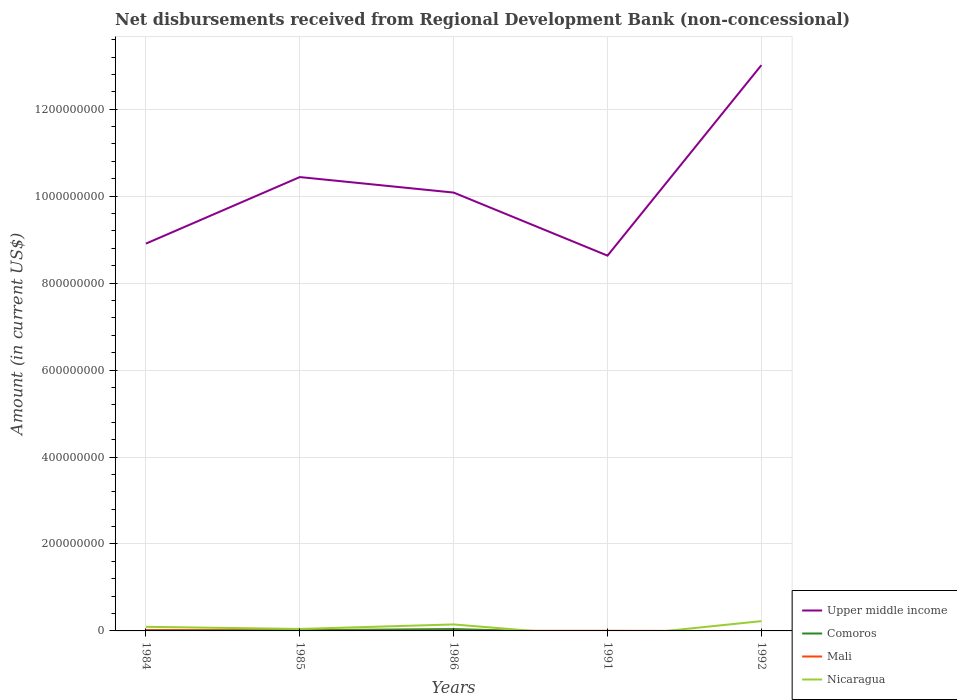How many different coloured lines are there?
Provide a short and direct response. 4. Does the line corresponding to Mali intersect with the line corresponding to Upper middle income?
Keep it short and to the point. No. Across all years, what is the maximum amount of disbursements received from Regional Development Bank in Comoros?
Your answer should be very brief. 0. What is the total amount of disbursements received from Regional Development Bank in Upper middle income in the graph?
Keep it short and to the point. -1.17e+08. What is the difference between the highest and the second highest amount of disbursements received from Regional Development Bank in Mali?
Keep it short and to the point. 1.83e+06. What is the difference between the highest and the lowest amount of disbursements received from Regional Development Bank in Mali?
Provide a short and direct response. 1. How many lines are there?
Provide a short and direct response. 4. What is the difference between two consecutive major ticks on the Y-axis?
Your answer should be compact. 2.00e+08. Does the graph contain any zero values?
Provide a succinct answer. Yes. Does the graph contain grids?
Offer a very short reply. Yes. How are the legend labels stacked?
Provide a succinct answer. Vertical. What is the title of the graph?
Offer a very short reply. Net disbursements received from Regional Development Bank (non-concessional). What is the label or title of the X-axis?
Your response must be concise. Years. What is the label or title of the Y-axis?
Keep it short and to the point. Amount (in current US$). What is the Amount (in current US$) in Upper middle income in 1984?
Offer a terse response. 8.91e+08. What is the Amount (in current US$) in Comoros in 1984?
Your answer should be very brief. 1.78e+06. What is the Amount (in current US$) of Mali in 1984?
Your response must be concise. 1.83e+06. What is the Amount (in current US$) of Nicaragua in 1984?
Make the answer very short. 9.44e+06. What is the Amount (in current US$) in Upper middle income in 1985?
Provide a succinct answer. 1.04e+09. What is the Amount (in current US$) of Comoros in 1985?
Ensure brevity in your answer.  1.66e+06. What is the Amount (in current US$) in Nicaragua in 1985?
Provide a short and direct response. 4.54e+06. What is the Amount (in current US$) of Upper middle income in 1986?
Provide a succinct answer. 1.01e+09. What is the Amount (in current US$) of Comoros in 1986?
Offer a very short reply. 4.27e+06. What is the Amount (in current US$) of Mali in 1986?
Offer a terse response. 3.03e+05. What is the Amount (in current US$) in Nicaragua in 1986?
Offer a terse response. 1.49e+07. What is the Amount (in current US$) of Upper middle income in 1991?
Your answer should be very brief. 8.63e+08. What is the Amount (in current US$) in Comoros in 1991?
Your answer should be very brief. 0. What is the Amount (in current US$) in Mali in 1991?
Your answer should be very brief. 2.45e+05. What is the Amount (in current US$) in Upper middle income in 1992?
Provide a succinct answer. 1.30e+09. What is the Amount (in current US$) of Mali in 1992?
Your response must be concise. 0. What is the Amount (in current US$) of Nicaragua in 1992?
Keep it short and to the point. 2.25e+07. Across all years, what is the maximum Amount (in current US$) in Upper middle income?
Offer a very short reply. 1.30e+09. Across all years, what is the maximum Amount (in current US$) of Comoros?
Give a very brief answer. 4.27e+06. Across all years, what is the maximum Amount (in current US$) in Mali?
Your answer should be very brief. 1.83e+06. Across all years, what is the maximum Amount (in current US$) in Nicaragua?
Make the answer very short. 2.25e+07. Across all years, what is the minimum Amount (in current US$) in Upper middle income?
Keep it short and to the point. 8.63e+08. Across all years, what is the minimum Amount (in current US$) of Comoros?
Give a very brief answer. 0. Across all years, what is the minimum Amount (in current US$) in Mali?
Provide a short and direct response. 0. What is the total Amount (in current US$) of Upper middle income in the graph?
Offer a very short reply. 5.11e+09. What is the total Amount (in current US$) in Comoros in the graph?
Make the answer very short. 7.71e+06. What is the total Amount (in current US$) of Mali in the graph?
Give a very brief answer. 2.78e+06. What is the total Amount (in current US$) in Nicaragua in the graph?
Your answer should be compact. 5.14e+07. What is the difference between the Amount (in current US$) of Upper middle income in 1984 and that in 1985?
Make the answer very short. -1.53e+08. What is the difference between the Amount (in current US$) of Comoros in 1984 and that in 1985?
Provide a succinct answer. 1.24e+05. What is the difference between the Amount (in current US$) in Mali in 1984 and that in 1985?
Ensure brevity in your answer.  1.43e+06. What is the difference between the Amount (in current US$) in Nicaragua in 1984 and that in 1985?
Keep it short and to the point. 4.90e+06. What is the difference between the Amount (in current US$) of Upper middle income in 1984 and that in 1986?
Make the answer very short. -1.17e+08. What is the difference between the Amount (in current US$) of Comoros in 1984 and that in 1986?
Ensure brevity in your answer.  -2.49e+06. What is the difference between the Amount (in current US$) of Mali in 1984 and that in 1986?
Make the answer very short. 1.53e+06. What is the difference between the Amount (in current US$) of Nicaragua in 1984 and that in 1986?
Your answer should be compact. -5.46e+06. What is the difference between the Amount (in current US$) in Upper middle income in 1984 and that in 1991?
Your answer should be very brief. 2.77e+07. What is the difference between the Amount (in current US$) of Mali in 1984 and that in 1991?
Offer a very short reply. 1.59e+06. What is the difference between the Amount (in current US$) of Upper middle income in 1984 and that in 1992?
Make the answer very short. -4.10e+08. What is the difference between the Amount (in current US$) in Nicaragua in 1984 and that in 1992?
Provide a short and direct response. -1.31e+07. What is the difference between the Amount (in current US$) in Upper middle income in 1985 and that in 1986?
Make the answer very short. 3.57e+07. What is the difference between the Amount (in current US$) of Comoros in 1985 and that in 1986?
Offer a very short reply. -2.62e+06. What is the difference between the Amount (in current US$) in Mali in 1985 and that in 1986?
Offer a terse response. 9.70e+04. What is the difference between the Amount (in current US$) of Nicaragua in 1985 and that in 1986?
Provide a succinct answer. -1.04e+07. What is the difference between the Amount (in current US$) of Upper middle income in 1985 and that in 1991?
Your answer should be very brief. 1.81e+08. What is the difference between the Amount (in current US$) in Mali in 1985 and that in 1991?
Your answer should be compact. 1.55e+05. What is the difference between the Amount (in current US$) of Upper middle income in 1985 and that in 1992?
Your answer should be very brief. -2.57e+08. What is the difference between the Amount (in current US$) of Nicaragua in 1985 and that in 1992?
Provide a short and direct response. -1.80e+07. What is the difference between the Amount (in current US$) in Upper middle income in 1986 and that in 1991?
Your answer should be compact. 1.45e+08. What is the difference between the Amount (in current US$) of Mali in 1986 and that in 1991?
Ensure brevity in your answer.  5.80e+04. What is the difference between the Amount (in current US$) of Upper middle income in 1986 and that in 1992?
Provide a short and direct response. -2.93e+08. What is the difference between the Amount (in current US$) of Nicaragua in 1986 and that in 1992?
Make the answer very short. -7.62e+06. What is the difference between the Amount (in current US$) in Upper middle income in 1991 and that in 1992?
Offer a terse response. -4.38e+08. What is the difference between the Amount (in current US$) in Upper middle income in 1984 and the Amount (in current US$) in Comoros in 1985?
Offer a terse response. 8.89e+08. What is the difference between the Amount (in current US$) in Upper middle income in 1984 and the Amount (in current US$) in Mali in 1985?
Provide a succinct answer. 8.90e+08. What is the difference between the Amount (in current US$) of Upper middle income in 1984 and the Amount (in current US$) of Nicaragua in 1985?
Ensure brevity in your answer.  8.86e+08. What is the difference between the Amount (in current US$) in Comoros in 1984 and the Amount (in current US$) in Mali in 1985?
Ensure brevity in your answer.  1.38e+06. What is the difference between the Amount (in current US$) in Comoros in 1984 and the Amount (in current US$) in Nicaragua in 1985?
Give a very brief answer. -2.76e+06. What is the difference between the Amount (in current US$) in Mali in 1984 and the Amount (in current US$) in Nicaragua in 1985?
Your answer should be compact. -2.71e+06. What is the difference between the Amount (in current US$) of Upper middle income in 1984 and the Amount (in current US$) of Comoros in 1986?
Offer a very short reply. 8.87e+08. What is the difference between the Amount (in current US$) of Upper middle income in 1984 and the Amount (in current US$) of Mali in 1986?
Ensure brevity in your answer.  8.91e+08. What is the difference between the Amount (in current US$) of Upper middle income in 1984 and the Amount (in current US$) of Nicaragua in 1986?
Your answer should be very brief. 8.76e+08. What is the difference between the Amount (in current US$) of Comoros in 1984 and the Amount (in current US$) of Mali in 1986?
Offer a terse response. 1.48e+06. What is the difference between the Amount (in current US$) of Comoros in 1984 and the Amount (in current US$) of Nicaragua in 1986?
Ensure brevity in your answer.  -1.31e+07. What is the difference between the Amount (in current US$) in Mali in 1984 and the Amount (in current US$) in Nicaragua in 1986?
Offer a very short reply. -1.31e+07. What is the difference between the Amount (in current US$) in Upper middle income in 1984 and the Amount (in current US$) in Mali in 1991?
Offer a terse response. 8.91e+08. What is the difference between the Amount (in current US$) in Comoros in 1984 and the Amount (in current US$) in Mali in 1991?
Give a very brief answer. 1.54e+06. What is the difference between the Amount (in current US$) in Upper middle income in 1984 and the Amount (in current US$) in Nicaragua in 1992?
Give a very brief answer. 8.68e+08. What is the difference between the Amount (in current US$) in Comoros in 1984 and the Amount (in current US$) in Nicaragua in 1992?
Give a very brief answer. -2.07e+07. What is the difference between the Amount (in current US$) of Mali in 1984 and the Amount (in current US$) of Nicaragua in 1992?
Offer a very short reply. -2.07e+07. What is the difference between the Amount (in current US$) in Upper middle income in 1985 and the Amount (in current US$) in Comoros in 1986?
Provide a short and direct response. 1.04e+09. What is the difference between the Amount (in current US$) of Upper middle income in 1985 and the Amount (in current US$) of Mali in 1986?
Offer a very short reply. 1.04e+09. What is the difference between the Amount (in current US$) in Upper middle income in 1985 and the Amount (in current US$) in Nicaragua in 1986?
Give a very brief answer. 1.03e+09. What is the difference between the Amount (in current US$) of Comoros in 1985 and the Amount (in current US$) of Mali in 1986?
Keep it short and to the point. 1.35e+06. What is the difference between the Amount (in current US$) of Comoros in 1985 and the Amount (in current US$) of Nicaragua in 1986?
Provide a succinct answer. -1.32e+07. What is the difference between the Amount (in current US$) of Mali in 1985 and the Amount (in current US$) of Nicaragua in 1986?
Keep it short and to the point. -1.45e+07. What is the difference between the Amount (in current US$) in Upper middle income in 1985 and the Amount (in current US$) in Mali in 1991?
Provide a short and direct response. 1.04e+09. What is the difference between the Amount (in current US$) in Comoros in 1985 and the Amount (in current US$) in Mali in 1991?
Make the answer very short. 1.41e+06. What is the difference between the Amount (in current US$) of Upper middle income in 1985 and the Amount (in current US$) of Nicaragua in 1992?
Your answer should be very brief. 1.02e+09. What is the difference between the Amount (in current US$) in Comoros in 1985 and the Amount (in current US$) in Nicaragua in 1992?
Offer a very short reply. -2.09e+07. What is the difference between the Amount (in current US$) in Mali in 1985 and the Amount (in current US$) in Nicaragua in 1992?
Ensure brevity in your answer.  -2.21e+07. What is the difference between the Amount (in current US$) of Upper middle income in 1986 and the Amount (in current US$) of Mali in 1991?
Your response must be concise. 1.01e+09. What is the difference between the Amount (in current US$) of Comoros in 1986 and the Amount (in current US$) of Mali in 1991?
Make the answer very short. 4.03e+06. What is the difference between the Amount (in current US$) in Upper middle income in 1986 and the Amount (in current US$) in Nicaragua in 1992?
Offer a very short reply. 9.86e+08. What is the difference between the Amount (in current US$) in Comoros in 1986 and the Amount (in current US$) in Nicaragua in 1992?
Offer a very short reply. -1.82e+07. What is the difference between the Amount (in current US$) in Mali in 1986 and the Amount (in current US$) in Nicaragua in 1992?
Offer a terse response. -2.22e+07. What is the difference between the Amount (in current US$) of Upper middle income in 1991 and the Amount (in current US$) of Nicaragua in 1992?
Your answer should be compact. 8.41e+08. What is the difference between the Amount (in current US$) in Mali in 1991 and the Amount (in current US$) in Nicaragua in 1992?
Your answer should be compact. -2.23e+07. What is the average Amount (in current US$) of Upper middle income per year?
Your answer should be compact. 1.02e+09. What is the average Amount (in current US$) of Comoros per year?
Offer a very short reply. 1.54e+06. What is the average Amount (in current US$) of Mali per year?
Your answer should be very brief. 5.56e+05. What is the average Amount (in current US$) in Nicaragua per year?
Ensure brevity in your answer.  1.03e+07. In the year 1984, what is the difference between the Amount (in current US$) of Upper middle income and Amount (in current US$) of Comoros?
Make the answer very short. 8.89e+08. In the year 1984, what is the difference between the Amount (in current US$) in Upper middle income and Amount (in current US$) in Mali?
Keep it short and to the point. 8.89e+08. In the year 1984, what is the difference between the Amount (in current US$) in Upper middle income and Amount (in current US$) in Nicaragua?
Make the answer very short. 8.81e+08. In the year 1984, what is the difference between the Amount (in current US$) in Comoros and Amount (in current US$) in Mali?
Your response must be concise. -5.20e+04. In the year 1984, what is the difference between the Amount (in current US$) of Comoros and Amount (in current US$) of Nicaragua?
Offer a terse response. -7.66e+06. In the year 1984, what is the difference between the Amount (in current US$) of Mali and Amount (in current US$) of Nicaragua?
Give a very brief answer. -7.61e+06. In the year 1985, what is the difference between the Amount (in current US$) in Upper middle income and Amount (in current US$) in Comoros?
Your answer should be compact. 1.04e+09. In the year 1985, what is the difference between the Amount (in current US$) in Upper middle income and Amount (in current US$) in Mali?
Ensure brevity in your answer.  1.04e+09. In the year 1985, what is the difference between the Amount (in current US$) of Upper middle income and Amount (in current US$) of Nicaragua?
Offer a terse response. 1.04e+09. In the year 1985, what is the difference between the Amount (in current US$) in Comoros and Amount (in current US$) in Mali?
Ensure brevity in your answer.  1.26e+06. In the year 1985, what is the difference between the Amount (in current US$) of Comoros and Amount (in current US$) of Nicaragua?
Keep it short and to the point. -2.88e+06. In the year 1985, what is the difference between the Amount (in current US$) of Mali and Amount (in current US$) of Nicaragua?
Keep it short and to the point. -4.14e+06. In the year 1986, what is the difference between the Amount (in current US$) in Upper middle income and Amount (in current US$) in Comoros?
Keep it short and to the point. 1.00e+09. In the year 1986, what is the difference between the Amount (in current US$) of Upper middle income and Amount (in current US$) of Mali?
Offer a terse response. 1.01e+09. In the year 1986, what is the difference between the Amount (in current US$) of Upper middle income and Amount (in current US$) of Nicaragua?
Make the answer very short. 9.93e+08. In the year 1986, what is the difference between the Amount (in current US$) of Comoros and Amount (in current US$) of Mali?
Keep it short and to the point. 3.97e+06. In the year 1986, what is the difference between the Amount (in current US$) of Comoros and Amount (in current US$) of Nicaragua?
Your answer should be very brief. -1.06e+07. In the year 1986, what is the difference between the Amount (in current US$) in Mali and Amount (in current US$) in Nicaragua?
Make the answer very short. -1.46e+07. In the year 1991, what is the difference between the Amount (in current US$) in Upper middle income and Amount (in current US$) in Mali?
Make the answer very short. 8.63e+08. In the year 1992, what is the difference between the Amount (in current US$) in Upper middle income and Amount (in current US$) in Nicaragua?
Make the answer very short. 1.28e+09. What is the ratio of the Amount (in current US$) in Upper middle income in 1984 to that in 1985?
Offer a very short reply. 0.85. What is the ratio of the Amount (in current US$) in Comoros in 1984 to that in 1985?
Provide a short and direct response. 1.07. What is the ratio of the Amount (in current US$) of Mali in 1984 to that in 1985?
Provide a succinct answer. 4.58. What is the ratio of the Amount (in current US$) in Nicaragua in 1984 to that in 1985?
Provide a short and direct response. 2.08. What is the ratio of the Amount (in current US$) in Upper middle income in 1984 to that in 1986?
Ensure brevity in your answer.  0.88. What is the ratio of the Amount (in current US$) in Comoros in 1984 to that in 1986?
Offer a very short reply. 0.42. What is the ratio of the Amount (in current US$) in Mali in 1984 to that in 1986?
Offer a very short reply. 6.05. What is the ratio of the Amount (in current US$) of Nicaragua in 1984 to that in 1986?
Make the answer very short. 0.63. What is the ratio of the Amount (in current US$) in Upper middle income in 1984 to that in 1991?
Give a very brief answer. 1.03. What is the ratio of the Amount (in current US$) of Mali in 1984 to that in 1991?
Your answer should be very brief. 7.48. What is the ratio of the Amount (in current US$) of Upper middle income in 1984 to that in 1992?
Make the answer very short. 0.68. What is the ratio of the Amount (in current US$) in Nicaragua in 1984 to that in 1992?
Your answer should be very brief. 0.42. What is the ratio of the Amount (in current US$) in Upper middle income in 1985 to that in 1986?
Your response must be concise. 1.04. What is the ratio of the Amount (in current US$) of Comoros in 1985 to that in 1986?
Provide a short and direct response. 0.39. What is the ratio of the Amount (in current US$) in Mali in 1985 to that in 1986?
Keep it short and to the point. 1.32. What is the ratio of the Amount (in current US$) in Nicaragua in 1985 to that in 1986?
Provide a short and direct response. 0.3. What is the ratio of the Amount (in current US$) of Upper middle income in 1985 to that in 1991?
Provide a short and direct response. 1.21. What is the ratio of the Amount (in current US$) of Mali in 1985 to that in 1991?
Your response must be concise. 1.63. What is the ratio of the Amount (in current US$) of Upper middle income in 1985 to that in 1992?
Your response must be concise. 0.8. What is the ratio of the Amount (in current US$) of Nicaragua in 1985 to that in 1992?
Offer a very short reply. 0.2. What is the ratio of the Amount (in current US$) of Upper middle income in 1986 to that in 1991?
Provide a short and direct response. 1.17. What is the ratio of the Amount (in current US$) of Mali in 1986 to that in 1991?
Your answer should be compact. 1.24. What is the ratio of the Amount (in current US$) of Upper middle income in 1986 to that in 1992?
Provide a succinct answer. 0.77. What is the ratio of the Amount (in current US$) of Nicaragua in 1986 to that in 1992?
Offer a very short reply. 0.66. What is the ratio of the Amount (in current US$) in Upper middle income in 1991 to that in 1992?
Your answer should be very brief. 0.66. What is the difference between the highest and the second highest Amount (in current US$) of Upper middle income?
Provide a short and direct response. 2.57e+08. What is the difference between the highest and the second highest Amount (in current US$) in Comoros?
Offer a terse response. 2.49e+06. What is the difference between the highest and the second highest Amount (in current US$) of Mali?
Provide a succinct answer. 1.43e+06. What is the difference between the highest and the second highest Amount (in current US$) in Nicaragua?
Offer a very short reply. 7.62e+06. What is the difference between the highest and the lowest Amount (in current US$) of Upper middle income?
Keep it short and to the point. 4.38e+08. What is the difference between the highest and the lowest Amount (in current US$) of Comoros?
Your answer should be compact. 4.27e+06. What is the difference between the highest and the lowest Amount (in current US$) of Mali?
Your answer should be compact. 1.83e+06. What is the difference between the highest and the lowest Amount (in current US$) of Nicaragua?
Give a very brief answer. 2.25e+07. 